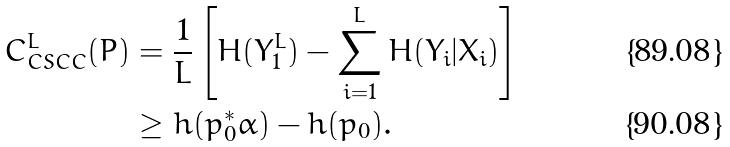Convert formula to latex. <formula><loc_0><loc_0><loc_500><loc_500>C _ { C S C C } ^ { L } ( P ) & = \frac { 1 } { L } \left [ H ( Y _ { 1 } ^ { L } ) - \sum _ { i = 1 } ^ { L } H ( Y _ { i } | X _ { i } ) \right ] \\ & \geq h ( p _ { 0 } ^ { * } \alpha ) - h ( p _ { 0 } ) .</formula> 